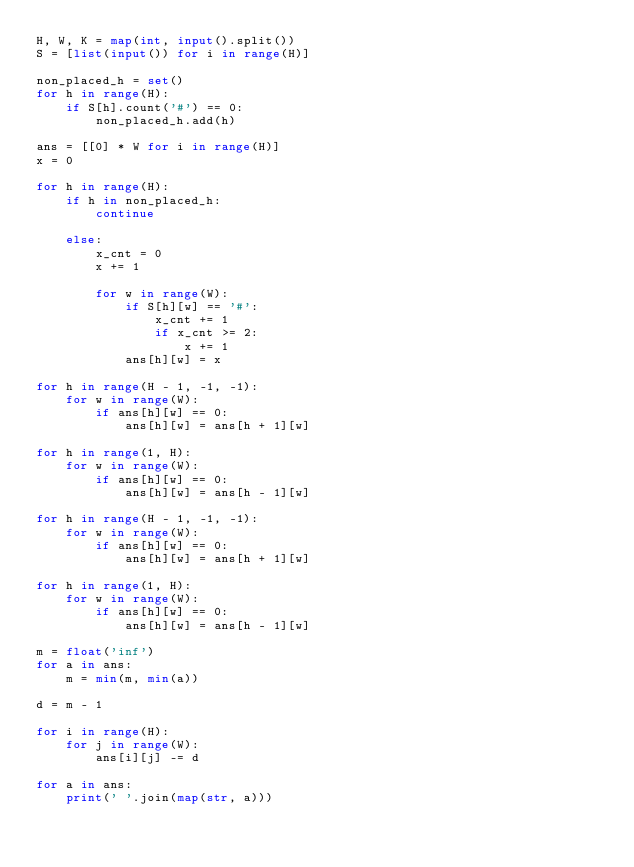<code> <loc_0><loc_0><loc_500><loc_500><_Python_>H, W, K = map(int, input().split())
S = [list(input()) for i in range(H)]

non_placed_h = set()
for h in range(H):
    if S[h].count('#') == 0:
        non_placed_h.add(h)

ans = [[0] * W for i in range(H)]
x = 0

for h in range(H):
    if h in non_placed_h:
        continue

    else:
        x_cnt = 0
        x += 1

        for w in range(W):
            if S[h][w] == '#':
                x_cnt += 1
                if x_cnt >= 2:
                    x += 1
            ans[h][w] = x

for h in range(H - 1, -1, -1):
    for w in range(W):
        if ans[h][w] == 0:
            ans[h][w] = ans[h + 1][w]

for h in range(1, H):
    for w in range(W):
        if ans[h][w] == 0:
            ans[h][w] = ans[h - 1][w]

for h in range(H - 1, -1, -1):
    for w in range(W):
        if ans[h][w] == 0:
            ans[h][w] = ans[h + 1][w]

for h in range(1, H):
    for w in range(W):
        if ans[h][w] == 0:
            ans[h][w] = ans[h - 1][w]

m = float('inf')
for a in ans:
    m = min(m, min(a))

d = m - 1

for i in range(H):
    for j in range(W):
        ans[i][j] -= d

for a in ans:
    print(' '.join(map(str, a)))

</code> 